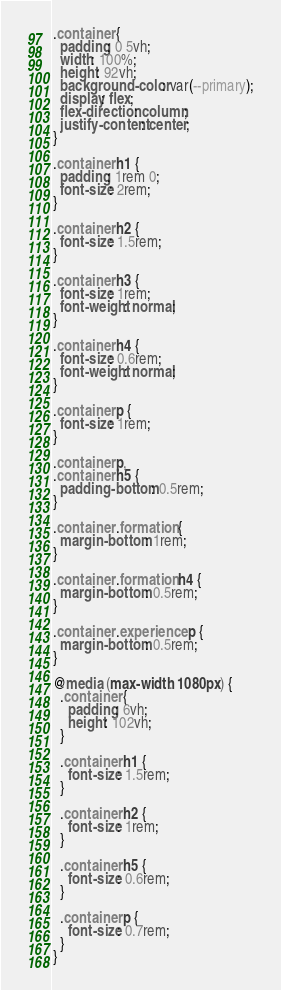<code> <loc_0><loc_0><loc_500><loc_500><_CSS_>.container {
  padding: 0 5vh;
  width: 100%;
  height: 92vh;
  background-color: var(--primary);
  display: flex;
  flex-direction: column;
  justify-content: center;
}

.container h1 {
  padding: 1rem 0;
  font-size: 2rem;
}

.container h2 {
  font-size: 1.5rem;
}

.container h3 {
  font-size: 1rem;
  font-weight: normal;
}

.container h4 {
  font-size: 0.6rem;
  font-weight: normal;
}

.container p {
  font-size: 1rem;
}

.container p,
.container h5 {
  padding-bottom: 0.5rem;
}

.container .formation {
  margin-bottom: 1rem;
}

.container .formation h4 {
  margin-bottom: 0.5rem;
}

.container .experience p {
  margin-bottom: 0.5rem;
}

@media (max-width: 1080px) {
  .container {
    padding: 6vh;
    height: 102vh;
  }

  .container h1 {
    font-size: 1.5rem;
  }

  .container h2 {
    font-size: 1rem;
  }

  .container h5 {
    font-size: 0.6rem;
  }

  .container p {
    font-size: 0.7rem;
  }
}
</code> 